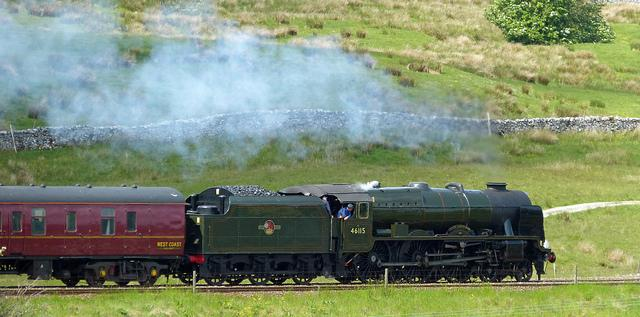Which car propels the train along the tracks? locomotive 